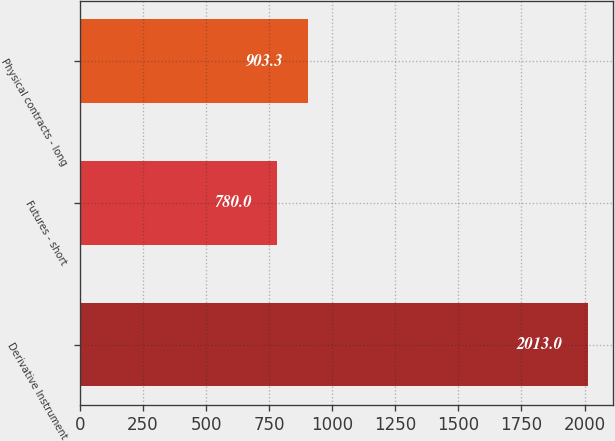Convert chart to OTSL. <chart><loc_0><loc_0><loc_500><loc_500><bar_chart><fcel>Derivative Instrument<fcel>Futures - short<fcel>Physical contracts - long<nl><fcel>2013<fcel>780<fcel>903.3<nl></chart> 